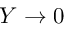<formula> <loc_0><loc_0><loc_500><loc_500>Y \rightarrow 0</formula> 